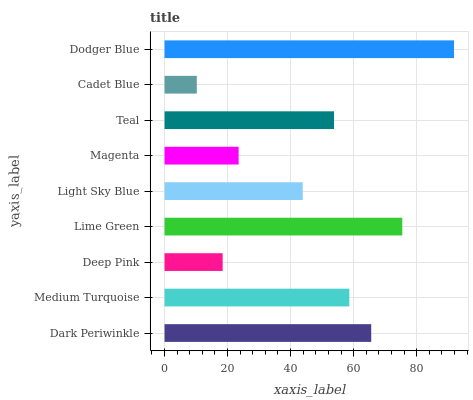Is Cadet Blue the minimum?
Answer yes or no. Yes. Is Dodger Blue the maximum?
Answer yes or no. Yes. Is Medium Turquoise the minimum?
Answer yes or no. No. Is Medium Turquoise the maximum?
Answer yes or no. No. Is Dark Periwinkle greater than Medium Turquoise?
Answer yes or no. Yes. Is Medium Turquoise less than Dark Periwinkle?
Answer yes or no. Yes. Is Medium Turquoise greater than Dark Periwinkle?
Answer yes or no. No. Is Dark Periwinkle less than Medium Turquoise?
Answer yes or no. No. Is Teal the high median?
Answer yes or no. Yes. Is Teal the low median?
Answer yes or no. Yes. Is Cadet Blue the high median?
Answer yes or no. No. Is Light Sky Blue the low median?
Answer yes or no. No. 